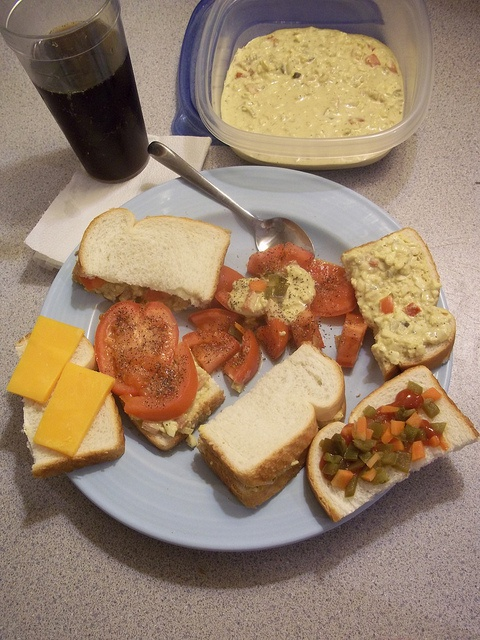Describe the objects in this image and their specific colors. I can see bowl in gray and tan tones, cup in gray and black tones, sandwich in gray, brown, maroon, and tan tones, sandwich in gray, tan, maroon, and brown tones, and sandwich in gray, tan, and maroon tones in this image. 